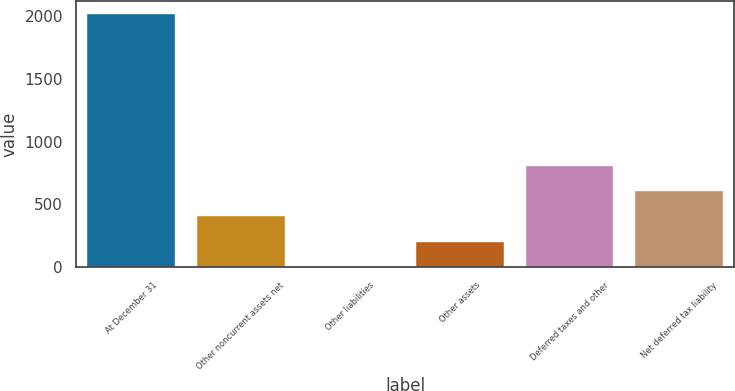<chart> <loc_0><loc_0><loc_500><loc_500><bar_chart><fcel>At December 31<fcel>Other noncurrent assets net<fcel>Other liabilities<fcel>Other assets<fcel>Deferred taxes and other<fcel>Net deferred tax liability<nl><fcel>2017<fcel>404.92<fcel>1.9<fcel>203.41<fcel>807.94<fcel>606.43<nl></chart> 